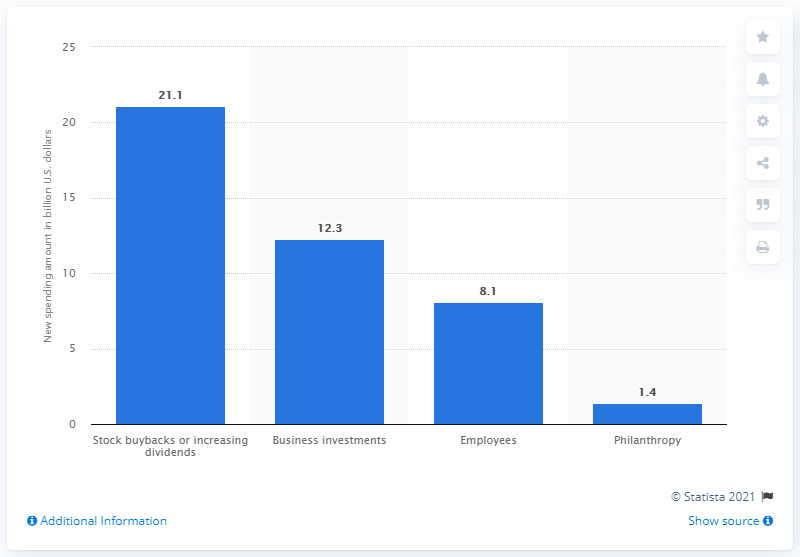List a handful of essential elements in this visual. The question is asking how much of the tax savings will be used to benefit employees. 